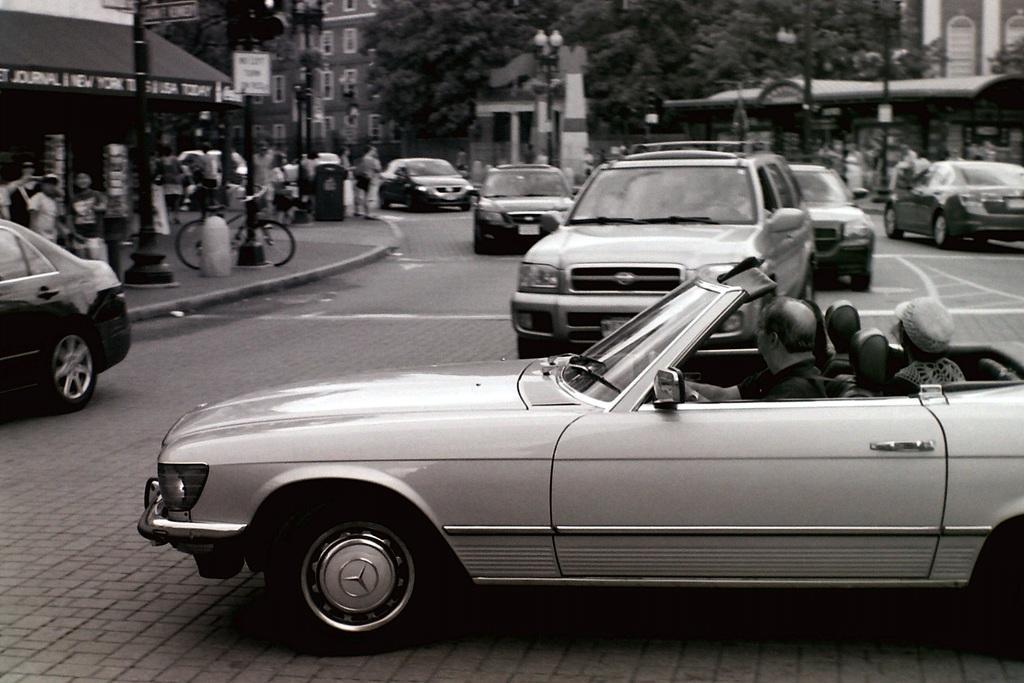Please provide a concise description of this image. In the center of the image we can see cars on the road and there are people sitting in the cars. In the background there are buildings, poles. On the left there are people and we can see a bicycle. 